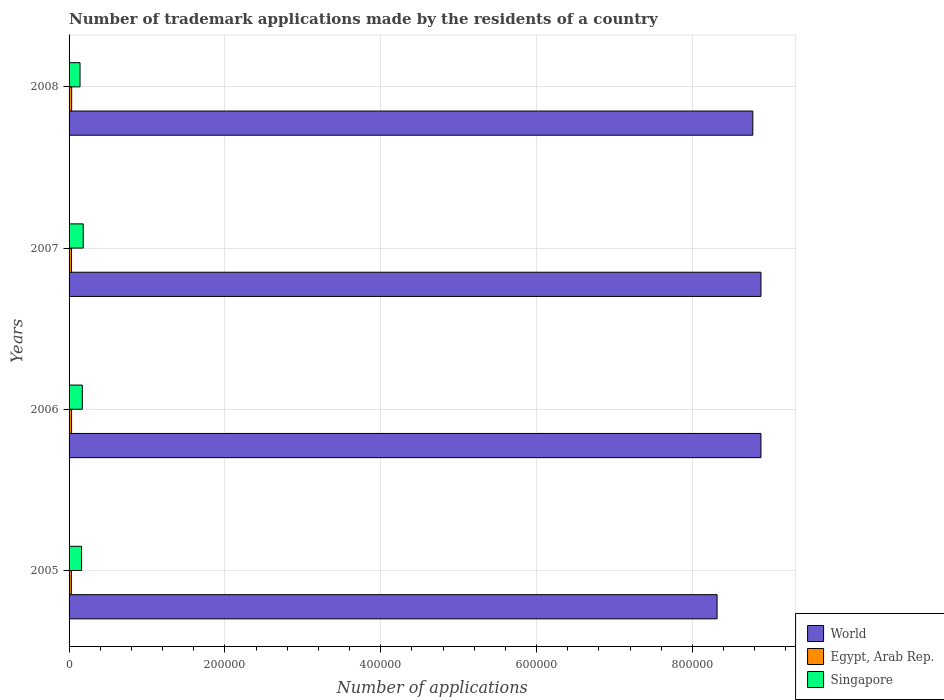How many different coloured bars are there?
Offer a terse response. 3. How many groups of bars are there?
Your response must be concise. 4. Are the number of bars per tick equal to the number of legend labels?
Provide a short and direct response. Yes. How many bars are there on the 4th tick from the top?
Give a very brief answer. 3. What is the label of the 3rd group of bars from the top?
Provide a short and direct response. 2006. What is the number of trademark applications made by the residents in Egypt, Arab Rep. in 2008?
Make the answer very short. 3340. Across all years, what is the maximum number of trademark applications made by the residents in Singapore?
Offer a terse response. 1.82e+04. Across all years, what is the minimum number of trademark applications made by the residents in World?
Give a very brief answer. 8.32e+05. In which year was the number of trademark applications made by the residents in World minimum?
Provide a short and direct response. 2005. What is the total number of trademark applications made by the residents in Singapore in the graph?
Provide a succinct answer. 6.53e+04. What is the difference between the number of trademark applications made by the residents in Egypt, Arab Rep. in 2006 and that in 2008?
Offer a very short reply. -132. What is the difference between the number of trademark applications made by the residents in Singapore in 2006 and the number of trademark applications made by the residents in World in 2008?
Your answer should be compact. -8.61e+05. What is the average number of trademark applications made by the residents in Egypt, Arab Rep. per year?
Make the answer very short. 3160.25. In the year 2007, what is the difference between the number of trademark applications made by the residents in Egypt, Arab Rep. and number of trademark applications made by the residents in World?
Make the answer very short. -8.85e+05. In how many years, is the number of trademark applications made by the residents in Singapore greater than 520000 ?
Provide a succinct answer. 0. What is the ratio of the number of trademark applications made by the residents in Singapore in 2006 to that in 2008?
Offer a very short reply. 1.21. What is the difference between the highest and the second highest number of trademark applications made by the residents in World?
Keep it short and to the point. 33. What is the difference between the highest and the lowest number of trademark applications made by the residents in Singapore?
Offer a terse response. 4115. Is the sum of the number of trademark applications made by the residents in World in 2006 and 2008 greater than the maximum number of trademark applications made by the residents in Singapore across all years?
Keep it short and to the point. Yes. What does the 1st bar from the top in 2005 represents?
Make the answer very short. Singapore. What does the 2nd bar from the bottom in 2008 represents?
Give a very brief answer. Egypt, Arab Rep. Is it the case that in every year, the sum of the number of trademark applications made by the residents in World and number of trademark applications made by the residents in Egypt, Arab Rep. is greater than the number of trademark applications made by the residents in Singapore?
Your answer should be very brief. Yes. How many years are there in the graph?
Offer a terse response. 4. Are the values on the major ticks of X-axis written in scientific E-notation?
Ensure brevity in your answer.  No. Does the graph contain any zero values?
Your response must be concise. No. How are the legend labels stacked?
Your response must be concise. Vertical. What is the title of the graph?
Make the answer very short. Number of trademark applications made by the residents of a country. Does "Virgin Islands" appear as one of the legend labels in the graph?
Make the answer very short. No. What is the label or title of the X-axis?
Make the answer very short. Number of applications. What is the Number of applications in World in 2005?
Offer a very short reply. 8.32e+05. What is the Number of applications in Egypt, Arab Rep. in 2005?
Keep it short and to the point. 2947. What is the Number of applications in Singapore in 2005?
Offer a terse response. 1.60e+04. What is the Number of applications in World in 2006?
Provide a short and direct response. 8.88e+05. What is the Number of applications of Egypt, Arab Rep. in 2006?
Offer a terse response. 3208. What is the Number of applications of Singapore in 2006?
Offer a terse response. 1.70e+04. What is the Number of applications in World in 2007?
Your response must be concise. 8.88e+05. What is the Number of applications of Egypt, Arab Rep. in 2007?
Provide a succinct answer. 3146. What is the Number of applications in Singapore in 2007?
Your answer should be compact. 1.82e+04. What is the Number of applications in World in 2008?
Your answer should be very brief. 8.78e+05. What is the Number of applications of Egypt, Arab Rep. in 2008?
Give a very brief answer. 3340. What is the Number of applications in Singapore in 2008?
Your answer should be compact. 1.41e+04. Across all years, what is the maximum Number of applications in World?
Your answer should be compact. 8.88e+05. Across all years, what is the maximum Number of applications in Egypt, Arab Rep.?
Offer a terse response. 3340. Across all years, what is the maximum Number of applications in Singapore?
Your answer should be very brief. 1.82e+04. Across all years, what is the minimum Number of applications of World?
Provide a succinct answer. 8.32e+05. Across all years, what is the minimum Number of applications of Egypt, Arab Rep.?
Make the answer very short. 2947. Across all years, what is the minimum Number of applications in Singapore?
Provide a short and direct response. 1.41e+04. What is the total Number of applications of World in the graph?
Provide a succinct answer. 3.49e+06. What is the total Number of applications of Egypt, Arab Rep. in the graph?
Make the answer very short. 1.26e+04. What is the total Number of applications in Singapore in the graph?
Make the answer very short. 6.53e+04. What is the difference between the Number of applications of World in 2005 and that in 2006?
Ensure brevity in your answer.  -5.63e+04. What is the difference between the Number of applications of Egypt, Arab Rep. in 2005 and that in 2006?
Provide a short and direct response. -261. What is the difference between the Number of applications in Singapore in 2005 and that in 2006?
Offer a very short reply. -988. What is the difference between the Number of applications in World in 2005 and that in 2007?
Your answer should be very brief. -5.63e+04. What is the difference between the Number of applications in Egypt, Arab Rep. in 2005 and that in 2007?
Offer a very short reply. -199. What is the difference between the Number of applications of Singapore in 2005 and that in 2007?
Provide a short and direct response. -2157. What is the difference between the Number of applications of World in 2005 and that in 2008?
Provide a succinct answer. -4.59e+04. What is the difference between the Number of applications in Egypt, Arab Rep. in 2005 and that in 2008?
Offer a terse response. -393. What is the difference between the Number of applications in Singapore in 2005 and that in 2008?
Your response must be concise. 1958. What is the difference between the Number of applications of World in 2006 and that in 2007?
Keep it short and to the point. -33. What is the difference between the Number of applications in Egypt, Arab Rep. in 2006 and that in 2007?
Ensure brevity in your answer.  62. What is the difference between the Number of applications in Singapore in 2006 and that in 2007?
Your response must be concise. -1169. What is the difference between the Number of applications of World in 2006 and that in 2008?
Your answer should be compact. 1.04e+04. What is the difference between the Number of applications of Egypt, Arab Rep. in 2006 and that in 2008?
Your answer should be compact. -132. What is the difference between the Number of applications in Singapore in 2006 and that in 2008?
Provide a short and direct response. 2946. What is the difference between the Number of applications in World in 2007 and that in 2008?
Offer a very short reply. 1.05e+04. What is the difference between the Number of applications in Egypt, Arab Rep. in 2007 and that in 2008?
Offer a terse response. -194. What is the difference between the Number of applications of Singapore in 2007 and that in 2008?
Offer a very short reply. 4115. What is the difference between the Number of applications of World in 2005 and the Number of applications of Egypt, Arab Rep. in 2006?
Your response must be concise. 8.29e+05. What is the difference between the Number of applications in World in 2005 and the Number of applications in Singapore in 2006?
Make the answer very short. 8.15e+05. What is the difference between the Number of applications in Egypt, Arab Rep. in 2005 and the Number of applications in Singapore in 2006?
Offer a terse response. -1.41e+04. What is the difference between the Number of applications in World in 2005 and the Number of applications in Egypt, Arab Rep. in 2007?
Your answer should be compact. 8.29e+05. What is the difference between the Number of applications of World in 2005 and the Number of applications of Singapore in 2007?
Ensure brevity in your answer.  8.14e+05. What is the difference between the Number of applications in Egypt, Arab Rep. in 2005 and the Number of applications in Singapore in 2007?
Offer a very short reply. -1.52e+04. What is the difference between the Number of applications in World in 2005 and the Number of applications in Egypt, Arab Rep. in 2008?
Provide a short and direct response. 8.28e+05. What is the difference between the Number of applications in World in 2005 and the Number of applications in Singapore in 2008?
Your response must be concise. 8.18e+05. What is the difference between the Number of applications in Egypt, Arab Rep. in 2005 and the Number of applications in Singapore in 2008?
Give a very brief answer. -1.11e+04. What is the difference between the Number of applications in World in 2006 and the Number of applications in Egypt, Arab Rep. in 2007?
Make the answer very short. 8.85e+05. What is the difference between the Number of applications of World in 2006 and the Number of applications of Singapore in 2007?
Give a very brief answer. 8.70e+05. What is the difference between the Number of applications of Egypt, Arab Rep. in 2006 and the Number of applications of Singapore in 2007?
Offer a very short reply. -1.50e+04. What is the difference between the Number of applications of World in 2006 and the Number of applications of Egypt, Arab Rep. in 2008?
Provide a short and direct response. 8.85e+05. What is the difference between the Number of applications in World in 2006 and the Number of applications in Singapore in 2008?
Offer a very short reply. 8.74e+05. What is the difference between the Number of applications of Egypt, Arab Rep. in 2006 and the Number of applications of Singapore in 2008?
Offer a terse response. -1.09e+04. What is the difference between the Number of applications in World in 2007 and the Number of applications in Egypt, Arab Rep. in 2008?
Make the answer very short. 8.85e+05. What is the difference between the Number of applications of World in 2007 and the Number of applications of Singapore in 2008?
Provide a succinct answer. 8.74e+05. What is the difference between the Number of applications in Egypt, Arab Rep. in 2007 and the Number of applications in Singapore in 2008?
Make the answer very short. -1.09e+04. What is the average Number of applications in World per year?
Provide a short and direct response. 8.71e+05. What is the average Number of applications in Egypt, Arab Rep. per year?
Offer a very short reply. 3160.25. What is the average Number of applications in Singapore per year?
Ensure brevity in your answer.  1.63e+04. In the year 2005, what is the difference between the Number of applications in World and Number of applications in Egypt, Arab Rep.?
Provide a succinct answer. 8.29e+05. In the year 2005, what is the difference between the Number of applications in World and Number of applications in Singapore?
Your answer should be compact. 8.16e+05. In the year 2005, what is the difference between the Number of applications of Egypt, Arab Rep. and Number of applications of Singapore?
Offer a terse response. -1.31e+04. In the year 2006, what is the difference between the Number of applications of World and Number of applications of Egypt, Arab Rep.?
Your response must be concise. 8.85e+05. In the year 2006, what is the difference between the Number of applications in World and Number of applications in Singapore?
Provide a short and direct response. 8.71e+05. In the year 2006, what is the difference between the Number of applications of Egypt, Arab Rep. and Number of applications of Singapore?
Your answer should be very brief. -1.38e+04. In the year 2007, what is the difference between the Number of applications in World and Number of applications in Egypt, Arab Rep.?
Offer a terse response. 8.85e+05. In the year 2007, what is the difference between the Number of applications of World and Number of applications of Singapore?
Provide a succinct answer. 8.70e+05. In the year 2007, what is the difference between the Number of applications of Egypt, Arab Rep. and Number of applications of Singapore?
Your response must be concise. -1.50e+04. In the year 2008, what is the difference between the Number of applications in World and Number of applications in Egypt, Arab Rep.?
Offer a terse response. 8.74e+05. In the year 2008, what is the difference between the Number of applications of World and Number of applications of Singapore?
Keep it short and to the point. 8.64e+05. In the year 2008, what is the difference between the Number of applications of Egypt, Arab Rep. and Number of applications of Singapore?
Keep it short and to the point. -1.07e+04. What is the ratio of the Number of applications in World in 2005 to that in 2006?
Offer a terse response. 0.94. What is the ratio of the Number of applications in Egypt, Arab Rep. in 2005 to that in 2006?
Provide a short and direct response. 0.92. What is the ratio of the Number of applications in Singapore in 2005 to that in 2006?
Make the answer very short. 0.94. What is the ratio of the Number of applications in World in 2005 to that in 2007?
Your answer should be compact. 0.94. What is the ratio of the Number of applications of Egypt, Arab Rep. in 2005 to that in 2007?
Your response must be concise. 0.94. What is the ratio of the Number of applications of Singapore in 2005 to that in 2007?
Offer a very short reply. 0.88. What is the ratio of the Number of applications in World in 2005 to that in 2008?
Keep it short and to the point. 0.95. What is the ratio of the Number of applications in Egypt, Arab Rep. in 2005 to that in 2008?
Offer a very short reply. 0.88. What is the ratio of the Number of applications of Singapore in 2005 to that in 2008?
Your answer should be compact. 1.14. What is the ratio of the Number of applications of Egypt, Arab Rep. in 2006 to that in 2007?
Your response must be concise. 1.02. What is the ratio of the Number of applications of Singapore in 2006 to that in 2007?
Provide a short and direct response. 0.94. What is the ratio of the Number of applications in World in 2006 to that in 2008?
Offer a very short reply. 1.01. What is the ratio of the Number of applications in Egypt, Arab Rep. in 2006 to that in 2008?
Provide a short and direct response. 0.96. What is the ratio of the Number of applications in Singapore in 2006 to that in 2008?
Give a very brief answer. 1.21. What is the ratio of the Number of applications of World in 2007 to that in 2008?
Offer a terse response. 1.01. What is the ratio of the Number of applications in Egypt, Arab Rep. in 2007 to that in 2008?
Offer a very short reply. 0.94. What is the ratio of the Number of applications of Singapore in 2007 to that in 2008?
Ensure brevity in your answer.  1.29. What is the difference between the highest and the second highest Number of applications of Egypt, Arab Rep.?
Keep it short and to the point. 132. What is the difference between the highest and the second highest Number of applications in Singapore?
Provide a succinct answer. 1169. What is the difference between the highest and the lowest Number of applications of World?
Make the answer very short. 5.63e+04. What is the difference between the highest and the lowest Number of applications of Egypt, Arab Rep.?
Keep it short and to the point. 393. What is the difference between the highest and the lowest Number of applications in Singapore?
Your answer should be very brief. 4115. 